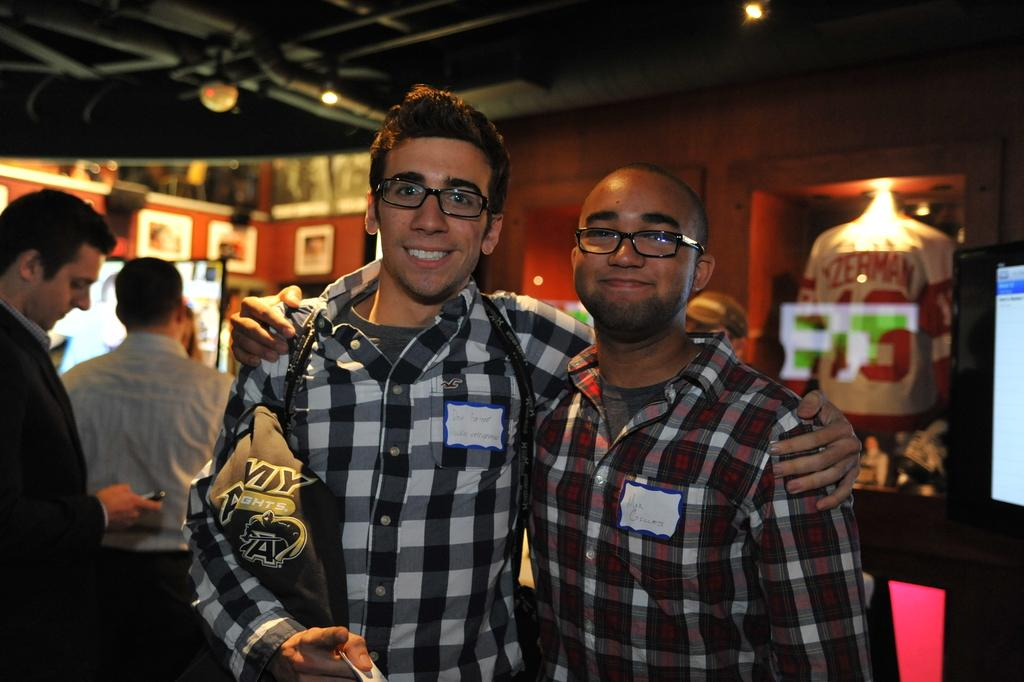What are the two persons in the image doing? The two persons in the image are standing and holding each other. Can you describe the background of the image? There are people and other objects in the background of the image. What type of sock is the person on the left wearing in the image? There is no sock visible in the image, as both persons are wearing shoes. Can you tell me how many pancakes are being flipped by the person in the background? There is no person flipping pancakes in the background of the image. 